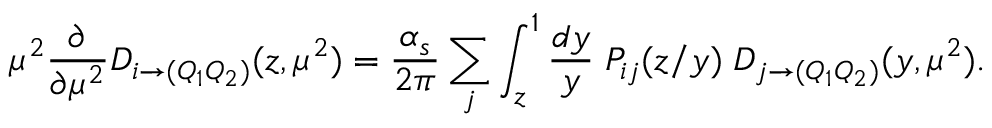<formula> <loc_0><loc_0><loc_500><loc_500>\mu ^ { 2 } \frac { \partial } { \partial \mu ^ { 2 } } D _ { i \to ( Q _ { 1 } Q _ { 2 } ) } ( z , \mu ^ { 2 } ) = \frac { \alpha _ { s } } { 2 \pi } \sum _ { j } \int _ { z } ^ { 1 } \frac { d y } { y } \, P _ { i j } ( z / y ) \, D _ { j \to ( Q _ { 1 } Q _ { 2 } ) } ( y , \mu ^ { 2 } ) .</formula> 